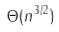Convert formula to latex. <formula><loc_0><loc_0><loc_500><loc_500>\Theta ( n ^ { 3 / 2 } )</formula> 